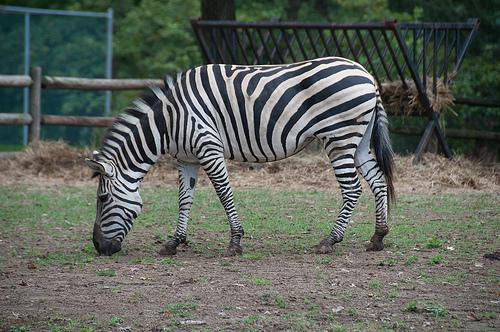Question: what animal is pictured?
Choices:
A. A lion.
B. A giraffe.
C. An elephant.
D. A zebra.
Answer with the letter. Answer: D Question: what is the zebra doing?
Choices:
A. Running.
B. Drinking.
C. Sleeping.
D. Eating.
Answer with the letter. Answer: D Question: why is the zebra's head bent down?
Choices:
A. Because it is sleeping.
B. Because it is eating.
C. Because it is drinking from a lake.
D. Because it is being petted.
Answer with the letter. Answer: B Question: where is this scene?
Choices:
A. A museum.
B. A zoo.
C. A forest.
D. An amusement park.
Answer with the letter. Answer: B Question: what is in the background?
Choices:
A. A house.
B. A feeding trough.
C. Some cars.
D. A large rock.
Answer with the letter. Answer: B 